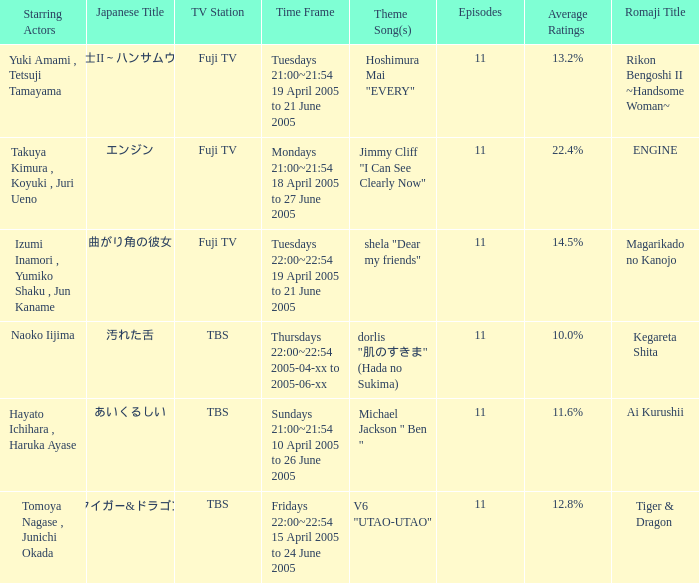Who is the star of the program on Thursdays 22:00~22:54 2005-04-xx to 2005-06-xx? Naoko Iijima. 